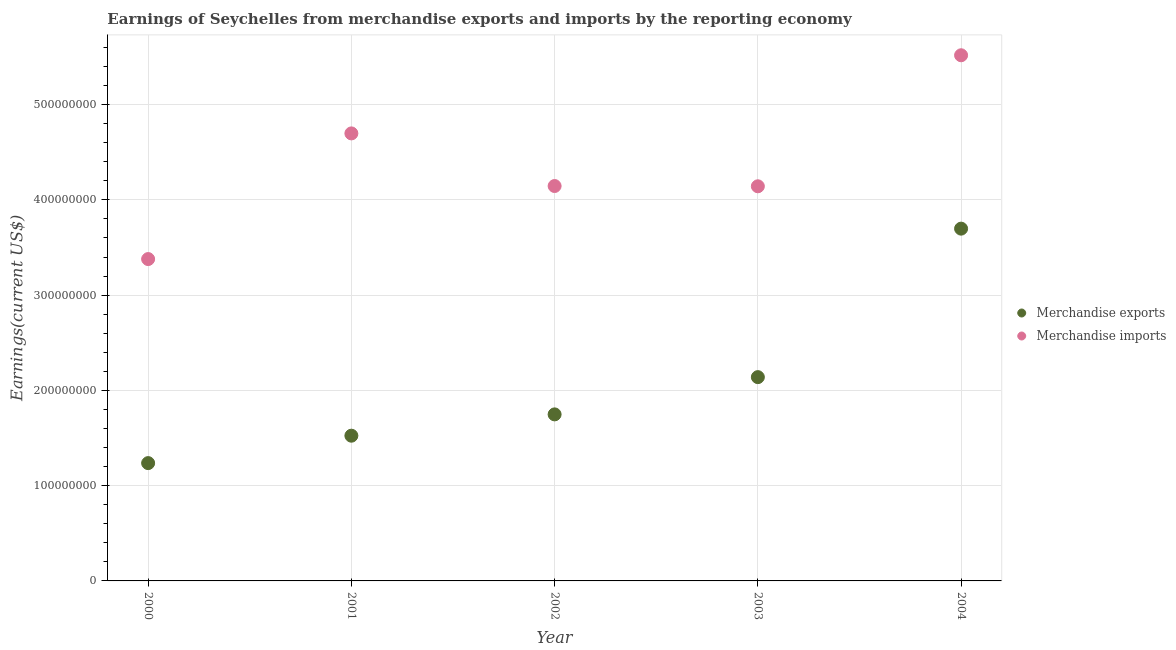How many different coloured dotlines are there?
Give a very brief answer. 2. Is the number of dotlines equal to the number of legend labels?
Your answer should be compact. Yes. What is the earnings from merchandise imports in 2001?
Keep it short and to the point. 4.70e+08. Across all years, what is the maximum earnings from merchandise imports?
Your answer should be very brief. 5.52e+08. Across all years, what is the minimum earnings from merchandise imports?
Provide a succinct answer. 3.38e+08. In which year was the earnings from merchandise exports minimum?
Make the answer very short. 2000. What is the total earnings from merchandise imports in the graph?
Your answer should be compact. 2.19e+09. What is the difference between the earnings from merchandise exports in 2003 and that in 2004?
Offer a very short reply. -1.56e+08. What is the difference between the earnings from merchandise imports in 2001 and the earnings from merchandise exports in 2000?
Your answer should be very brief. 3.46e+08. What is the average earnings from merchandise exports per year?
Provide a succinct answer. 2.07e+08. In the year 2000, what is the difference between the earnings from merchandise exports and earnings from merchandise imports?
Give a very brief answer. -2.14e+08. In how many years, is the earnings from merchandise exports greater than 240000000 US$?
Offer a very short reply. 1. What is the ratio of the earnings from merchandise exports in 2000 to that in 2003?
Offer a very short reply. 0.58. Is the earnings from merchandise imports in 2001 less than that in 2004?
Your answer should be very brief. Yes. What is the difference between the highest and the second highest earnings from merchandise exports?
Provide a succinct answer. 1.56e+08. What is the difference between the highest and the lowest earnings from merchandise exports?
Your answer should be compact. 2.46e+08. Is the earnings from merchandise exports strictly less than the earnings from merchandise imports over the years?
Your answer should be very brief. Yes. How many dotlines are there?
Offer a very short reply. 2. How many years are there in the graph?
Offer a terse response. 5. What is the difference between two consecutive major ticks on the Y-axis?
Provide a short and direct response. 1.00e+08. Are the values on the major ticks of Y-axis written in scientific E-notation?
Provide a succinct answer. No. Does the graph contain any zero values?
Keep it short and to the point. No. Does the graph contain grids?
Ensure brevity in your answer.  Yes. How many legend labels are there?
Give a very brief answer. 2. What is the title of the graph?
Ensure brevity in your answer.  Earnings of Seychelles from merchandise exports and imports by the reporting economy. What is the label or title of the X-axis?
Give a very brief answer. Year. What is the label or title of the Y-axis?
Offer a terse response. Earnings(current US$). What is the Earnings(current US$) in Merchandise exports in 2000?
Give a very brief answer. 1.24e+08. What is the Earnings(current US$) in Merchandise imports in 2000?
Provide a short and direct response. 3.38e+08. What is the Earnings(current US$) of Merchandise exports in 2001?
Offer a terse response. 1.52e+08. What is the Earnings(current US$) of Merchandise imports in 2001?
Ensure brevity in your answer.  4.70e+08. What is the Earnings(current US$) of Merchandise exports in 2002?
Provide a short and direct response. 1.75e+08. What is the Earnings(current US$) of Merchandise imports in 2002?
Make the answer very short. 4.15e+08. What is the Earnings(current US$) in Merchandise exports in 2003?
Provide a short and direct response. 2.14e+08. What is the Earnings(current US$) of Merchandise imports in 2003?
Give a very brief answer. 4.14e+08. What is the Earnings(current US$) in Merchandise exports in 2004?
Keep it short and to the point. 3.70e+08. What is the Earnings(current US$) of Merchandise imports in 2004?
Your answer should be compact. 5.52e+08. Across all years, what is the maximum Earnings(current US$) in Merchandise exports?
Your answer should be compact. 3.70e+08. Across all years, what is the maximum Earnings(current US$) in Merchandise imports?
Keep it short and to the point. 5.52e+08. Across all years, what is the minimum Earnings(current US$) of Merchandise exports?
Your answer should be very brief. 1.24e+08. Across all years, what is the minimum Earnings(current US$) of Merchandise imports?
Make the answer very short. 3.38e+08. What is the total Earnings(current US$) in Merchandise exports in the graph?
Offer a terse response. 1.03e+09. What is the total Earnings(current US$) in Merchandise imports in the graph?
Provide a short and direct response. 2.19e+09. What is the difference between the Earnings(current US$) in Merchandise exports in 2000 and that in 2001?
Keep it short and to the point. -2.88e+07. What is the difference between the Earnings(current US$) in Merchandise imports in 2000 and that in 2001?
Provide a succinct answer. -1.32e+08. What is the difference between the Earnings(current US$) of Merchandise exports in 2000 and that in 2002?
Provide a succinct answer. -5.12e+07. What is the difference between the Earnings(current US$) of Merchandise imports in 2000 and that in 2002?
Make the answer very short. -7.67e+07. What is the difference between the Earnings(current US$) of Merchandise exports in 2000 and that in 2003?
Offer a very short reply. -9.03e+07. What is the difference between the Earnings(current US$) in Merchandise imports in 2000 and that in 2003?
Your response must be concise. -7.64e+07. What is the difference between the Earnings(current US$) in Merchandise exports in 2000 and that in 2004?
Make the answer very short. -2.46e+08. What is the difference between the Earnings(current US$) of Merchandise imports in 2000 and that in 2004?
Provide a succinct answer. -2.14e+08. What is the difference between the Earnings(current US$) of Merchandise exports in 2001 and that in 2002?
Ensure brevity in your answer.  -2.24e+07. What is the difference between the Earnings(current US$) in Merchandise imports in 2001 and that in 2002?
Offer a very short reply. 5.52e+07. What is the difference between the Earnings(current US$) of Merchandise exports in 2001 and that in 2003?
Provide a succinct answer. -6.15e+07. What is the difference between the Earnings(current US$) in Merchandise imports in 2001 and that in 2003?
Provide a succinct answer. 5.55e+07. What is the difference between the Earnings(current US$) in Merchandise exports in 2001 and that in 2004?
Your answer should be compact. -2.17e+08. What is the difference between the Earnings(current US$) in Merchandise imports in 2001 and that in 2004?
Offer a terse response. -8.20e+07. What is the difference between the Earnings(current US$) of Merchandise exports in 2002 and that in 2003?
Provide a succinct answer. -3.91e+07. What is the difference between the Earnings(current US$) of Merchandise imports in 2002 and that in 2003?
Give a very brief answer. 2.82e+05. What is the difference between the Earnings(current US$) in Merchandise exports in 2002 and that in 2004?
Provide a short and direct response. -1.95e+08. What is the difference between the Earnings(current US$) in Merchandise imports in 2002 and that in 2004?
Your response must be concise. -1.37e+08. What is the difference between the Earnings(current US$) of Merchandise exports in 2003 and that in 2004?
Ensure brevity in your answer.  -1.56e+08. What is the difference between the Earnings(current US$) of Merchandise imports in 2003 and that in 2004?
Provide a short and direct response. -1.38e+08. What is the difference between the Earnings(current US$) in Merchandise exports in 2000 and the Earnings(current US$) in Merchandise imports in 2001?
Keep it short and to the point. -3.46e+08. What is the difference between the Earnings(current US$) in Merchandise exports in 2000 and the Earnings(current US$) in Merchandise imports in 2002?
Keep it short and to the point. -2.91e+08. What is the difference between the Earnings(current US$) in Merchandise exports in 2000 and the Earnings(current US$) in Merchandise imports in 2003?
Offer a very short reply. -2.91e+08. What is the difference between the Earnings(current US$) of Merchandise exports in 2000 and the Earnings(current US$) of Merchandise imports in 2004?
Make the answer very short. -4.28e+08. What is the difference between the Earnings(current US$) of Merchandise exports in 2001 and the Earnings(current US$) of Merchandise imports in 2002?
Provide a short and direct response. -2.62e+08. What is the difference between the Earnings(current US$) of Merchandise exports in 2001 and the Earnings(current US$) of Merchandise imports in 2003?
Give a very brief answer. -2.62e+08. What is the difference between the Earnings(current US$) of Merchandise exports in 2001 and the Earnings(current US$) of Merchandise imports in 2004?
Your answer should be very brief. -3.99e+08. What is the difference between the Earnings(current US$) of Merchandise exports in 2002 and the Earnings(current US$) of Merchandise imports in 2003?
Keep it short and to the point. -2.39e+08. What is the difference between the Earnings(current US$) in Merchandise exports in 2002 and the Earnings(current US$) in Merchandise imports in 2004?
Your answer should be compact. -3.77e+08. What is the difference between the Earnings(current US$) of Merchandise exports in 2003 and the Earnings(current US$) of Merchandise imports in 2004?
Your response must be concise. -3.38e+08. What is the average Earnings(current US$) of Merchandise exports per year?
Make the answer very short. 2.07e+08. What is the average Earnings(current US$) in Merchandise imports per year?
Your answer should be very brief. 4.38e+08. In the year 2000, what is the difference between the Earnings(current US$) in Merchandise exports and Earnings(current US$) in Merchandise imports?
Make the answer very short. -2.14e+08. In the year 2001, what is the difference between the Earnings(current US$) in Merchandise exports and Earnings(current US$) in Merchandise imports?
Ensure brevity in your answer.  -3.17e+08. In the year 2002, what is the difference between the Earnings(current US$) in Merchandise exports and Earnings(current US$) in Merchandise imports?
Your answer should be very brief. -2.40e+08. In the year 2003, what is the difference between the Earnings(current US$) of Merchandise exports and Earnings(current US$) of Merchandise imports?
Provide a short and direct response. -2.00e+08. In the year 2004, what is the difference between the Earnings(current US$) in Merchandise exports and Earnings(current US$) in Merchandise imports?
Offer a terse response. -1.82e+08. What is the ratio of the Earnings(current US$) in Merchandise exports in 2000 to that in 2001?
Your answer should be very brief. 0.81. What is the ratio of the Earnings(current US$) of Merchandise imports in 2000 to that in 2001?
Provide a short and direct response. 0.72. What is the ratio of the Earnings(current US$) in Merchandise exports in 2000 to that in 2002?
Give a very brief answer. 0.71. What is the ratio of the Earnings(current US$) of Merchandise imports in 2000 to that in 2002?
Your answer should be compact. 0.81. What is the ratio of the Earnings(current US$) in Merchandise exports in 2000 to that in 2003?
Your answer should be very brief. 0.58. What is the ratio of the Earnings(current US$) in Merchandise imports in 2000 to that in 2003?
Offer a very short reply. 0.82. What is the ratio of the Earnings(current US$) of Merchandise exports in 2000 to that in 2004?
Make the answer very short. 0.33. What is the ratio of the Earnings(current US$) of Merchandise imports in 2000 to that in 2004?
Make the answer very short. 0.61. What is the ratio of the Earnings(current US$) in Merchandise exports in 2001 to that in 2002?
Make the answer very short. 0.87. What is the ratio of the Earnings(current US$) in Merchandise imports in 2001 to that in 2002?
Offer a terse response. 1.13. What is the ratio of the Earnings(current US$) of Merchandise exports in 2001 to that in 2003?
Your answer should be compact. 0.71. What is the ratio of the Earnings(current US$) in Merchandise imports in 2001 to that in 2003?
Provide a succinct answer. 1.13. What is the ratio of the Earnings(current US$) in Merchandise exports in 2001 to that in 2004?
Provide a short and direct response. 0.41. What is the ratio of the Earnings(current US$) of Merchandise imports in 2001 to that in 2004?
Your answer should be very brief. 0.85. What is the ratio of the Earnings(current US$) of Merchandise exports in 2002 to that in 2003?
Give a very brief answer. 0.82. What is the ratio of the Earnings(current US$) of Merchandise imports in 2002 to that in 2003?
Offer a very short reply. 1. What is the ratio of the Earnings(current US$) of Merchandise exports in 2002 to that in 2004?
Make the answer very short. 0.47. What is the ratio of the Earnings(current US$) in Merchandise imports in 2002 to that in 2004?
Give a very brief answer. 0.75. What is the ratio of the Earnings(current US$) of Merchandise exports in 2003 to that in 2004?
Ensure brevity in your answer.  0.58. What is the ratio of the Earnings(current US$) in Merchandise imports in 2003 to that in 2004?
Offer a terse response. 0.75. What is the difference between the highest and the second highest Earnings(current US$) of Merchandise exports?
Offer a terse response. 1.56e+08. What is the difference between the highest and the second highest Earnings(current US$) in Merchandise imports?
Ensure brevity in your answer.  8.20e+07. What is the difference between the highest and the lowest Earnings(current US$) of Merchandise exports?
Offer a terse response. 2.46e+08. What is the difference between the highest and the lowest Earnings(current US$) in Merchandise imports?
Provide a succinct answer. 2.14e+08. 